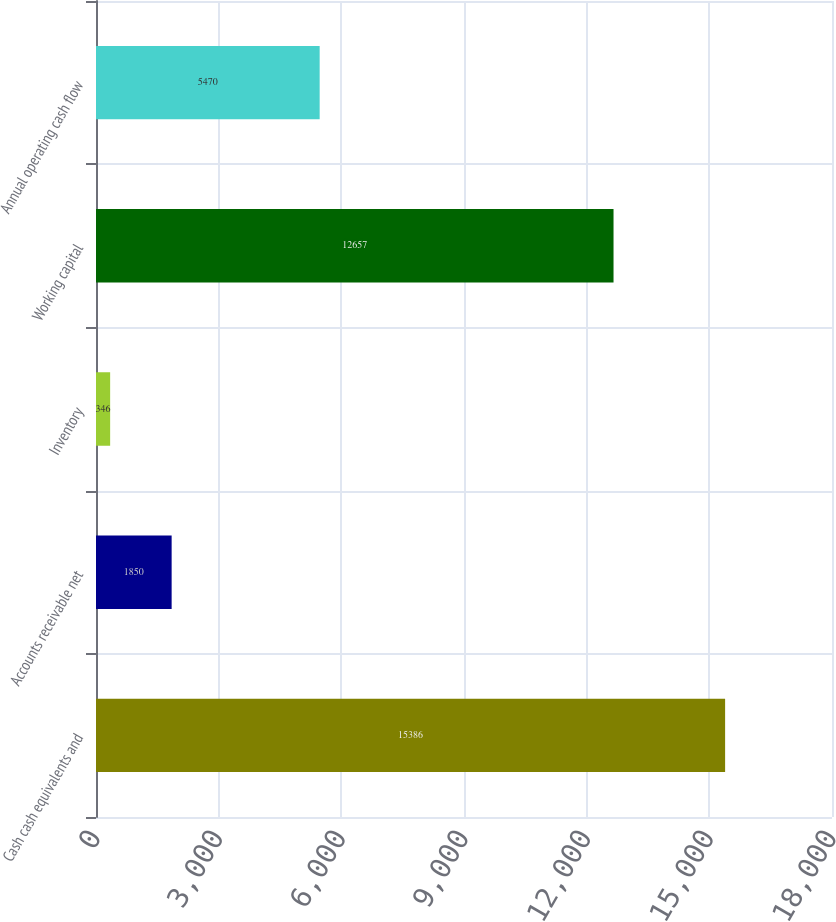<chart> <loc_0><loc_0><loc_500><loc_500><bar_chart><fcel>Cash cash equivalents and<fcel>Accounts receivable net<fcel>Inventory<fcel>Working capital<fcel>Annual operating cash flow<nl><fcel>15386<fcel>1850<fcel>346<fcel>12657<fcel>5470<nl></chart> 